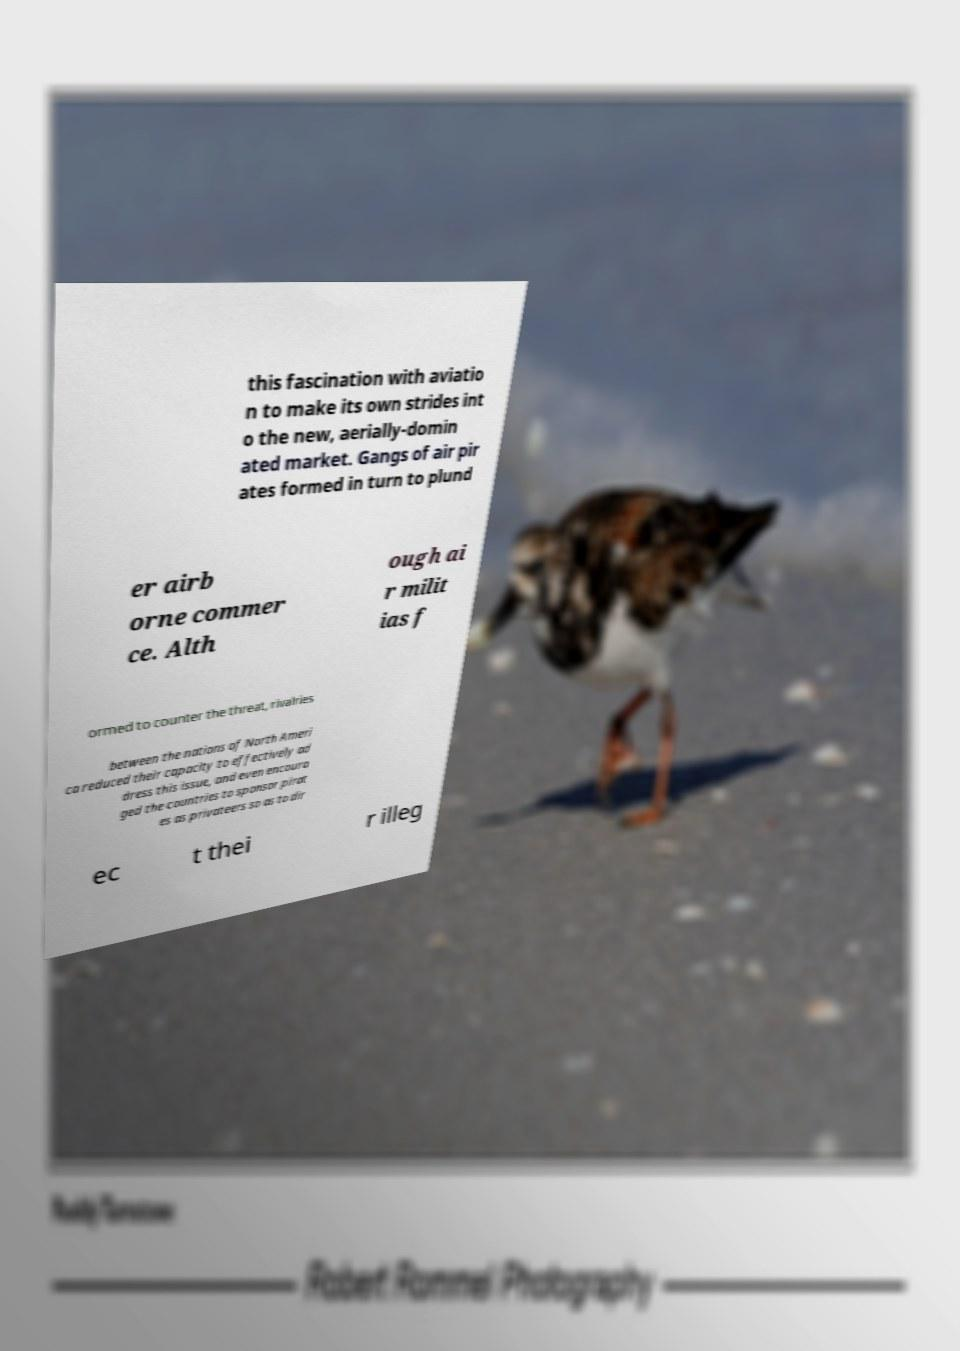Could you extract and type out the text from this image? this fascination with aviatio n to make its own strides int o the new, aerially-domin ated market. Gangs of air pir ates formed in turn to plund er airb orne commer ce. Alth ough ai r milit ias f ormed to counter the threat, rivalries between the nations of North Ameri ca reduced their capacity to effectively ad dress this issue, and even encoura ged the countries to sponsor pirat es as privateers so as to dir ec t thei r illeg 